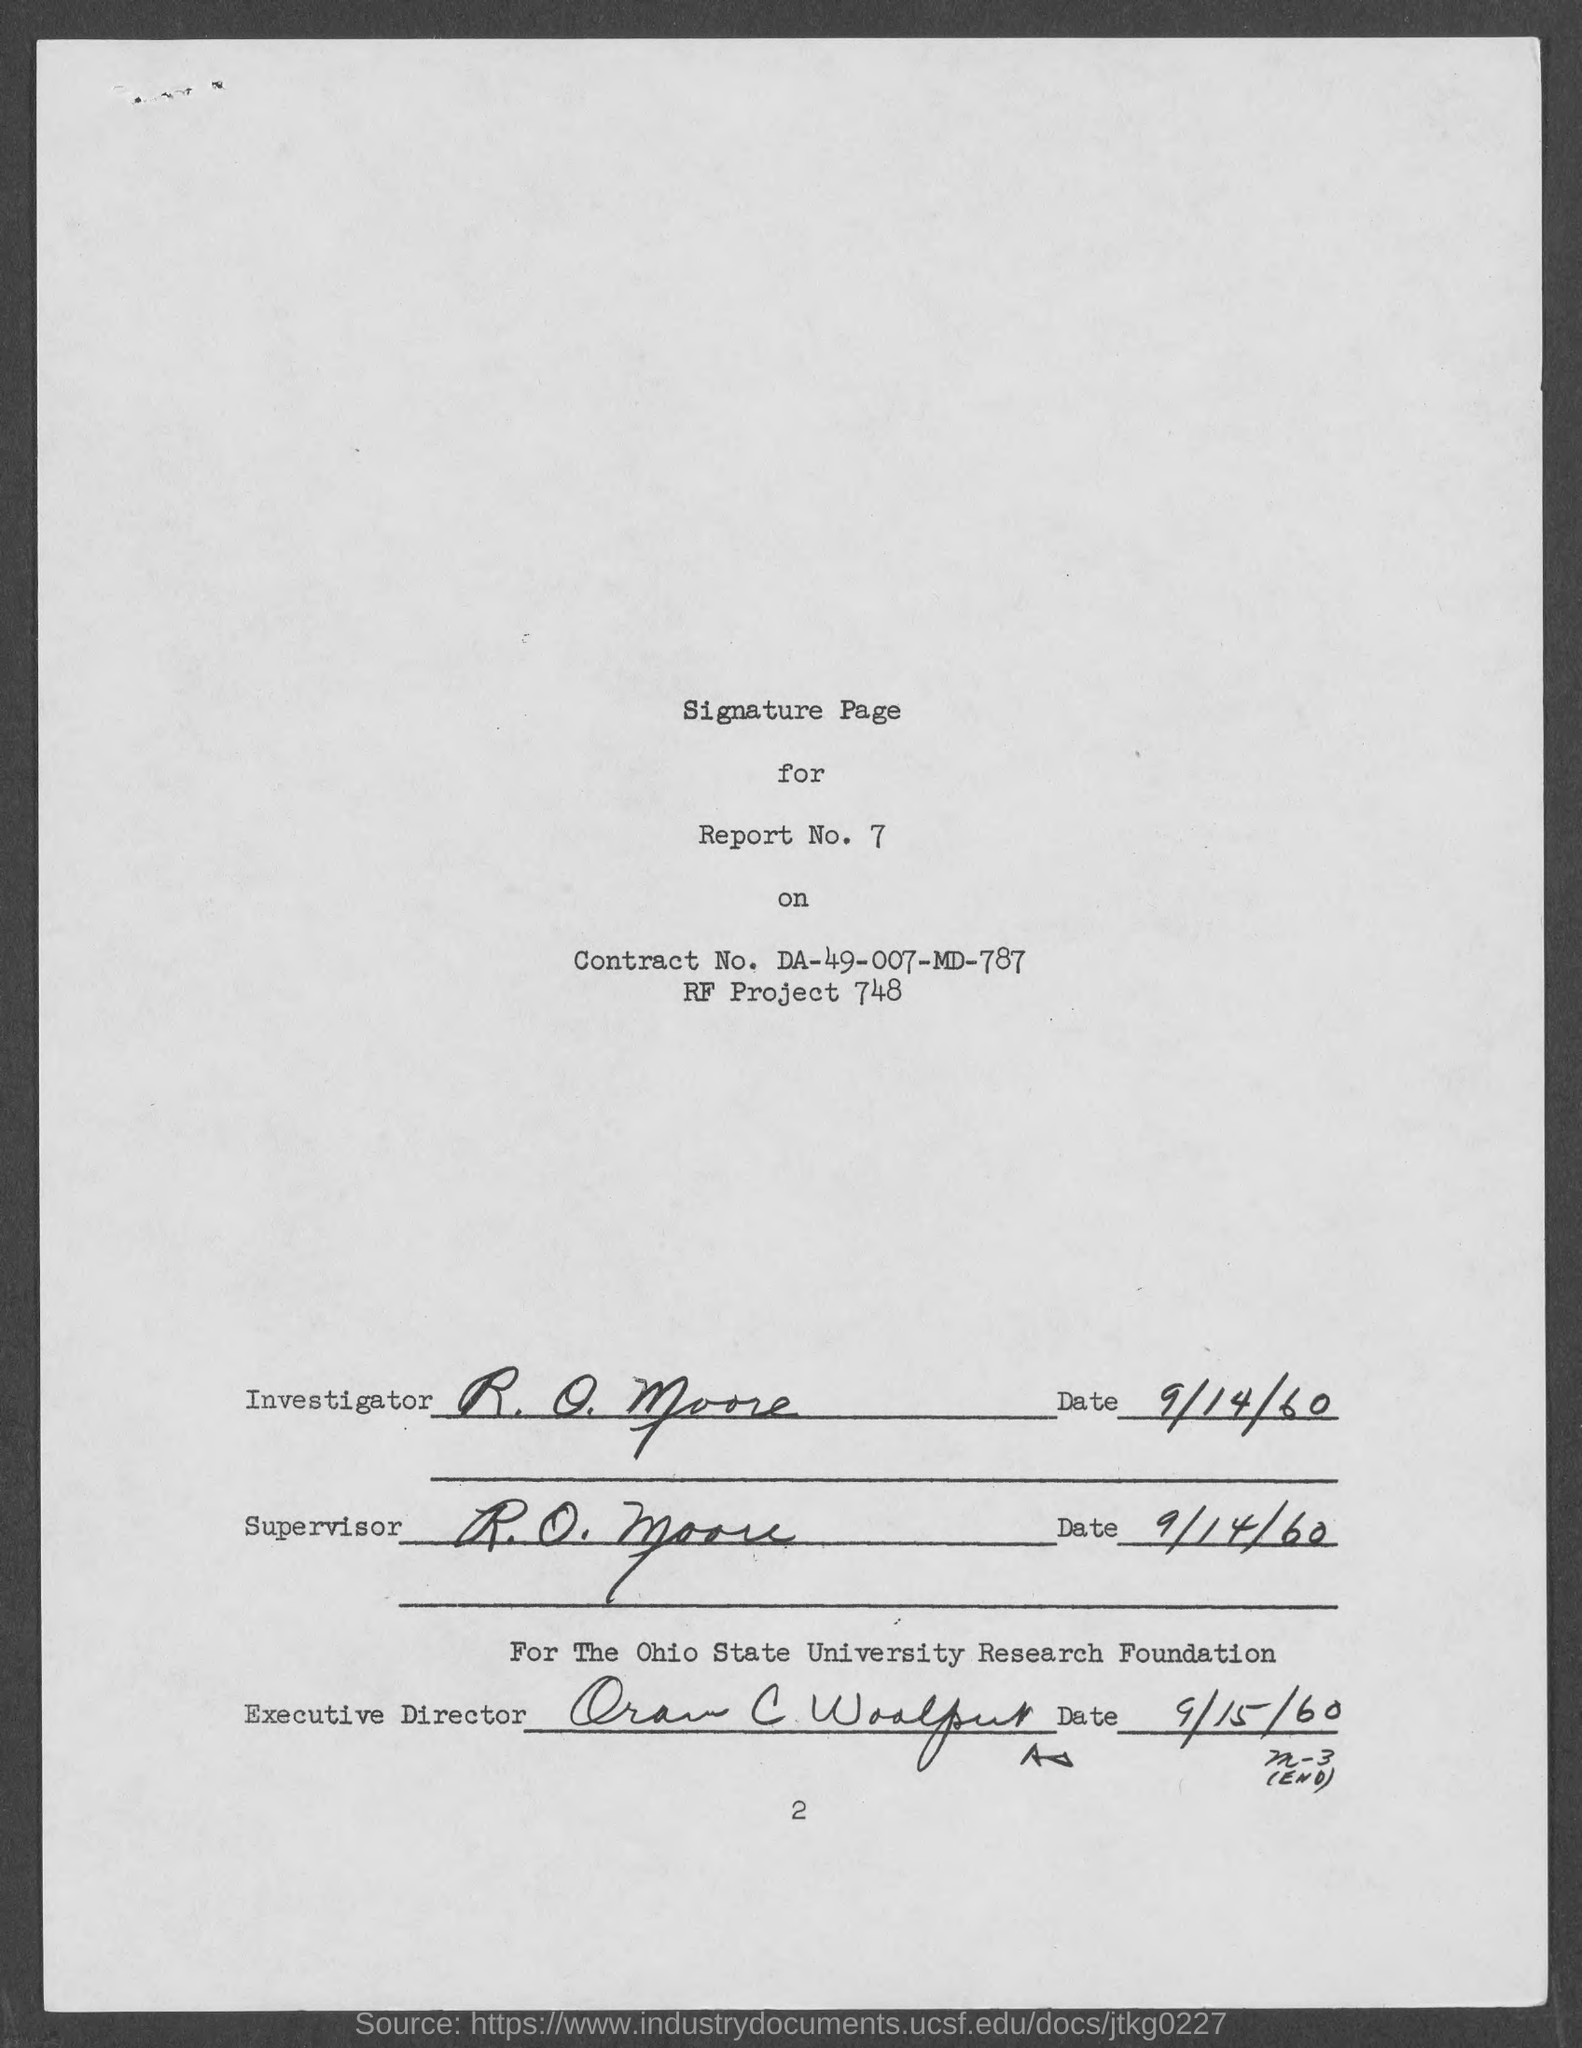What is report no.?
Offer a terse response. 7. What is RF project No.?
Keep it short and to the point. 748. What is date corresponding to "Supervisor"?
Provide a succinct answer. 9/14/60. 